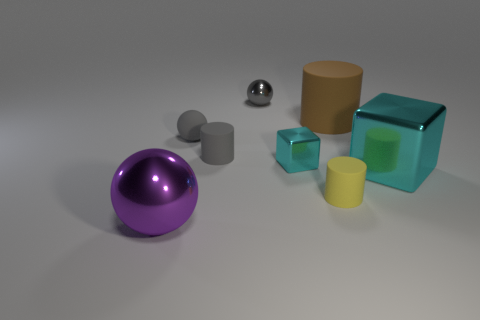There is a tiny rubber object that is the same color as the small matte sphere; what is its shape?
Your answer should be compact. Cylinder. How many brown rubber objects are the same shape as the yellow matte thing?
Keep it short and to the point. 1. What is the material of the yellow object that is the same shape as the brown object?
Your answer should be compact. Rubber. What is the material of the large block behind the tiny yellow cylinder left of the brown cylinder?
Ensure brevity in your answer.  Metal. There is a big object left of the gray metallic object; does it have the same shape as the matte object that is in front of the tiny metal cube?
Give a very brief answer. No. Are there the same number of tiny gray balls on the right side of the tiny gray rubber cylinder and yellow rubber things?
Provide a short and direct response. Yes. There is a object that is behind the big brown thing; are there any rubber cylinders to the right of it?
Ensure brevity in your answer.  Yes. Are there any other things of the same color as the large block?
Keep it short and to the point. Yes. Is the gray ball in front of the small gray metallic sphere made of the same material as the brown cylinder?
Your response must be concise. Yes. Are there the same number of yellow things that are on the right side of the large brown cylinder and big cyan metal things on the right side of the big cyan object?
Your answer should be compact. Yes. 